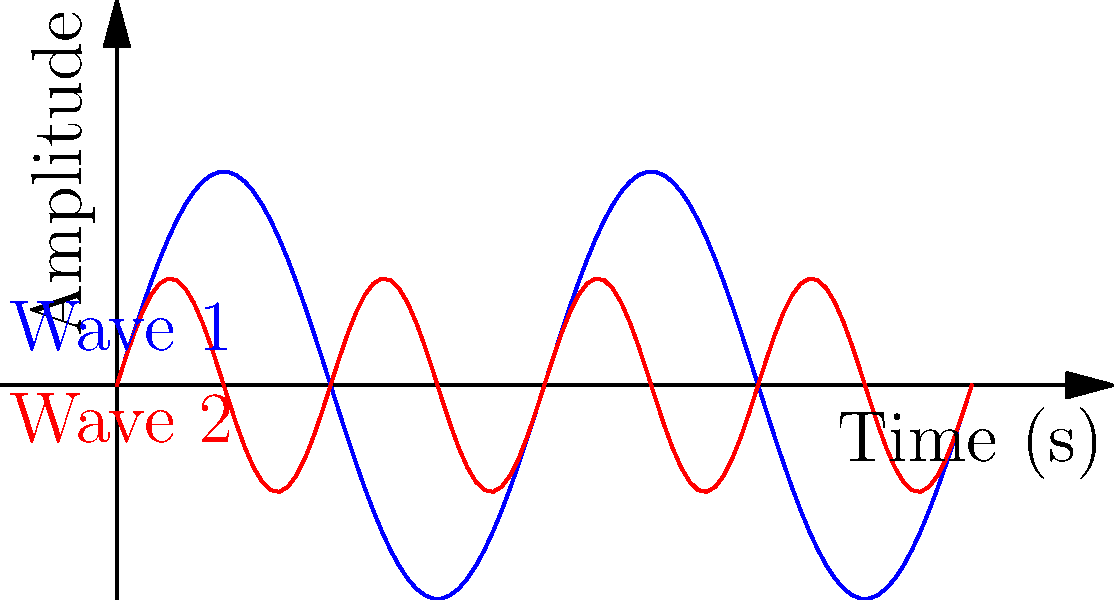In your latest article about The Verve Pipe's sound engineering techniques, you're analyzing two audio waveforms represented as sine waves. Wave 1 (blue) is given by the function $f(x)=0.5\sin(2\pi x)$, and Wave 2 (red) is given by $g(x)=0.25\sin(4\pi x)$, where $x$ represents time in seconds. If these waveforms span a 2-second interval, what is the total length of both curves combined? To find the total length of both curves, we need to calculate the arc length of each curve and then sum them up. The formula for arc length is:

$$L = \int_a^b \sqrt{1 + \left(\frac{df}{dx}\right)^2} dx$$

For Wave 1: $f(x)=0.5\sin(2\pi x)$
1. $\frac{df}{dx} = 0.5 \cdot 2\pi \cos(2\pi x) = \pi \cos(2\pi x)$
2. $L_1 = \int_0^2 \sqrt{1 + (\pi \cos(2\pi x))^2} dx$

For Wave 2: $g(x)=0.25\sin(4\pi x)$
1. $\frac{dg}{dx} = 0.25 \cdot 4\pi \cos(4\pi x) = \pi \cos(4\pi x)$
2. $L_2 = \int_0^2 \sqrt{1 + (\pi \cos(4\pi x))^2} dx$

The total length is $L_{total} = L_1 + L_2$

These integrals don't have elementary antiderivatives, so we need to use numerical integration methods to approximate the result. Using a computer algebra system or numerical integration tool, we get:

$L_1 \approx 2.2841$
$L_2 \approx 2.1511$

$L_{total} \approx 2.2841 + 2.1511 = 4.4352$
Answer: $4.4352$ units 